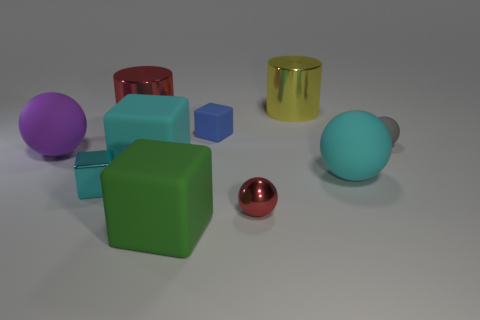Do the matte thing that is in front of the cyan sphere and the shiny cylinder on the left side of the yellow metal cylinder have the same size?
Give a very brief answer. Yes. What size is the purple sphere that is the same material as the large green cube?
Your answer should be compact. Large. What number of things are both to the left of the small blue block and in front of the cyan metallic cube?
Your response must be concise. 1. What number of objects are either blue rubber cubes or blocks that are in front of the small gray matte sphere?
Ensure brevity in your answer.  4. There is a large metallic object that is the same color as the shiny sphere; what shape is it?
Provide a succinct answer. Cylinder. What is the color of the cylinder that is to the left of the big green rubber cube?
Offer a terse response. Red. How many things are either big metallic cylinders in front of the yellow metallic cylinder or big objects?
Make the answer very short. 6. What color is the shiny sphere that is the same size as the blue rubber object?
Offer a terse response. Red. Is the number of small gray balls on the left side of the tiny blue thing greater than the number of green cubes?
Provide a succinct answer. No. What material is the sphere that is in front of the gray sphere and on the right side of the large yellow metallic cylinder?
Provide a short and direct response. Rubber. 